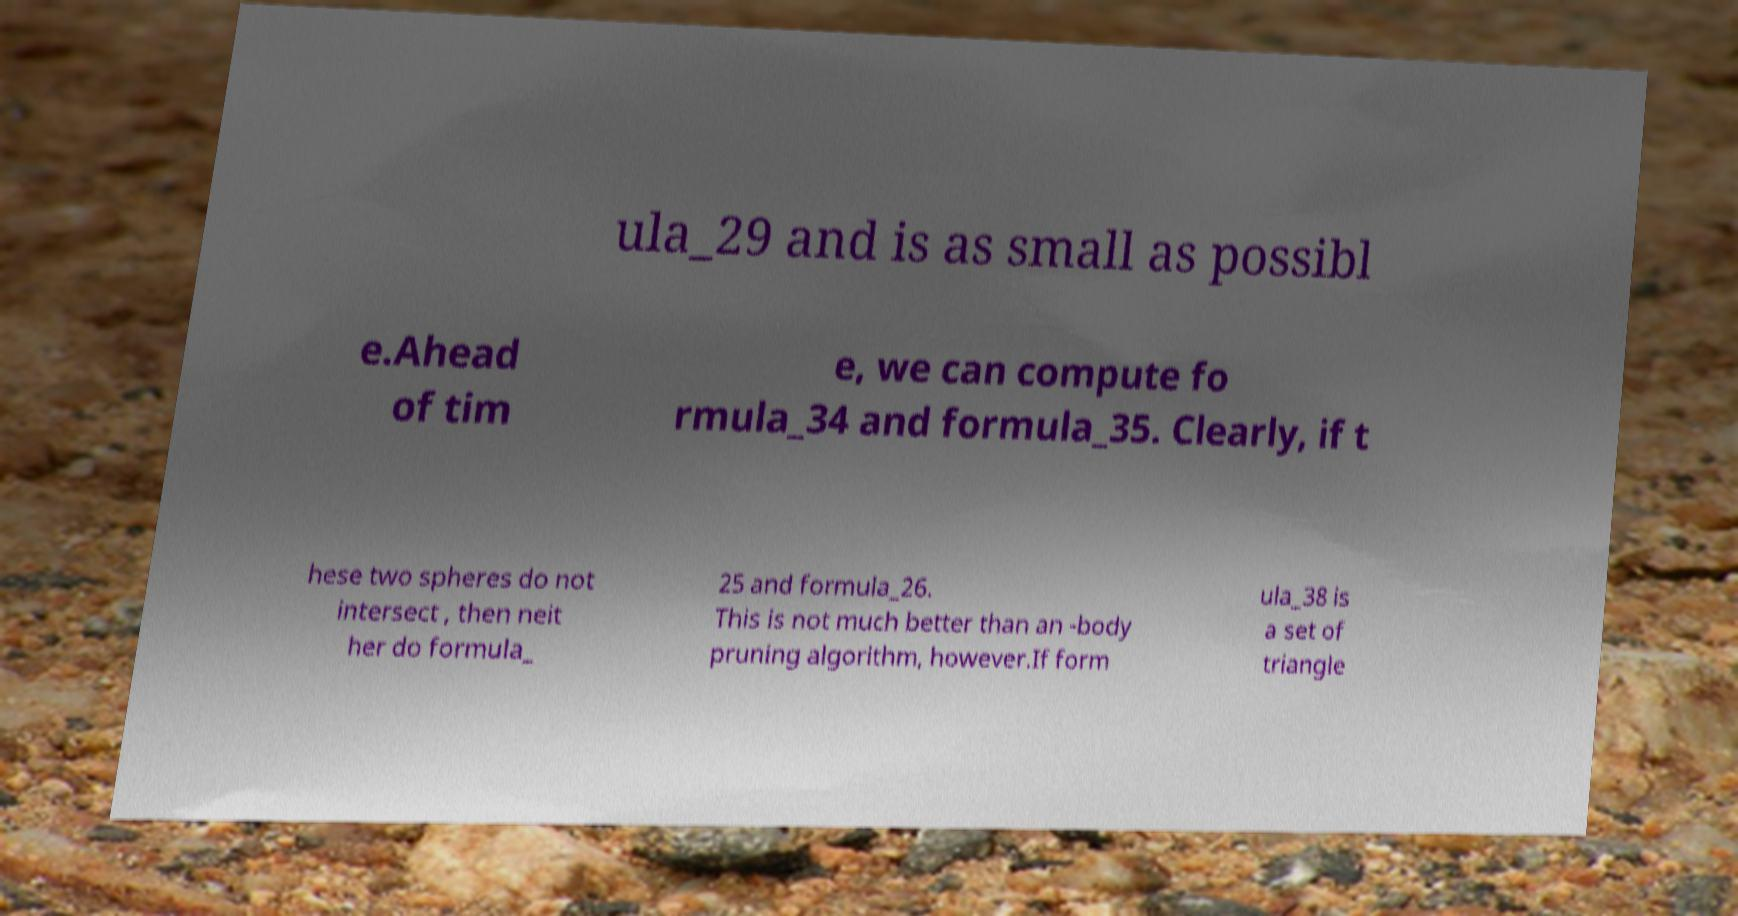Please identify and transcribe the text found in this image. ula_29 and is as small as possibl e.Ahead of tim e, we can compute fo rmula_34 and formula_35. Clearly, if t hese two spheres do not intersect , then neit her do formula_ 25 and formula_26. This is not much better than an -body pruning algorithm, however.If form ula_38 is a set of triangle 